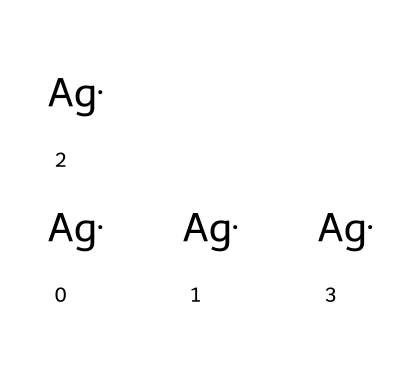What is the main element in this structure? The structure consists of only silver atoms represented by the symbol 'Ag'. This indicates that silver is the main and only element present.
Answer: silver How many silver atoms are present? The SMILES representation shows four instances of 'Ag', which means there are a total of four silver atoms in the nanoparticle.
Answer: four What type of chemical structure is represented here? The presence of multiple silver atoms with no other elements suggests that this compound is a metallic nanoparticle, specifically silver nanoparticles.
Answer: metallic nanoparticle What potential property do silver nanoparticles impart to pet accessories? Silver nanoparticles are known for their antibacterial properties, which can help in reducing microbial growth on pet accessories.
Answer: antibacterial Why are silver nanoparticles used in pet accessories? Their unique properties, such as antimicrobial activity and reduced risk of infection, make them beneficial for use in pet products.
Answer: antimicrobial activity What is a common application of silver nanoparticles? Silver nanoparticles are commonly used in coatings for medical devices due to their ability to inhibit bacteria growth.
Answer: medical devices How does the size of these nanoparticles generally compare to conventional silver? Silver nanoparticles are typically in the range of 1 to 100 nanometers, which is much smaller than conventional silver particles.
Answer: smaller 